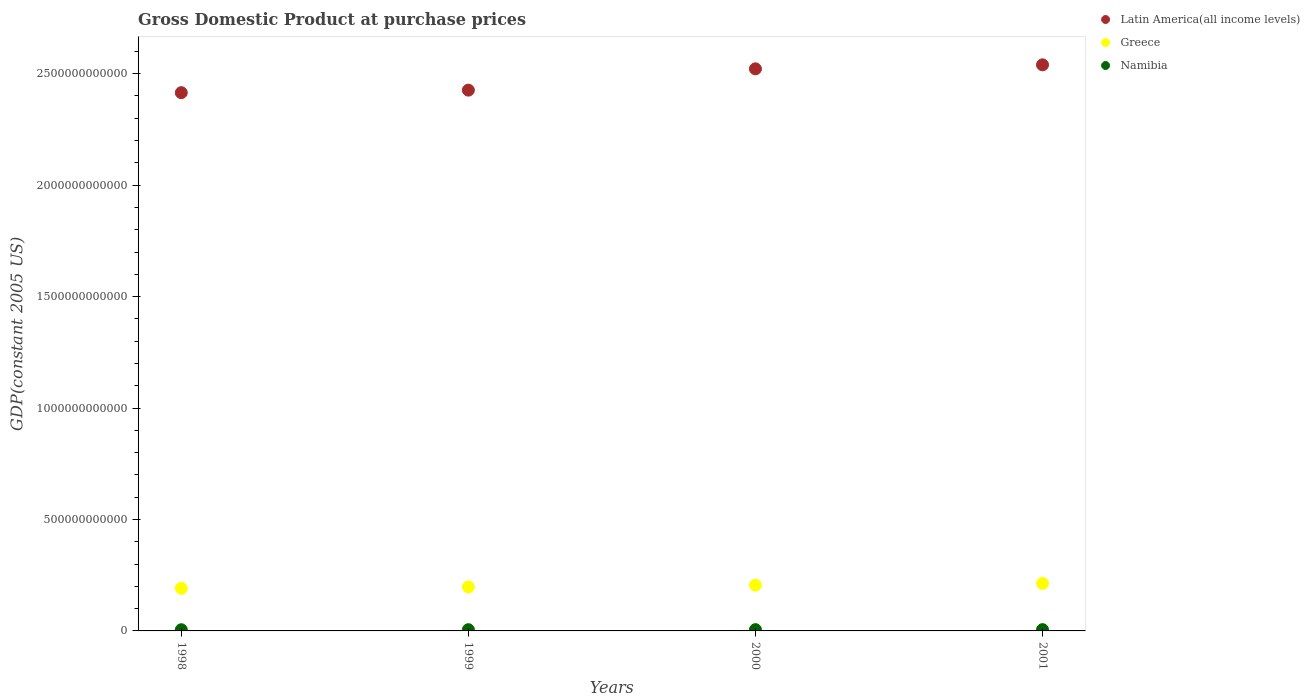How many different coloured dotlines are there?
Make the answer very short. 3. Is the number of dotlines equal to the number of legend labels?
Give a very brief answer. Yes. What is the GDP at purchase prices in Namibia in 2001?
Your answer should be compact. 5.78e+09. Across all years, what is the maximum GDP at purchase prices in Namibia?
Your response must be concise. 5.78e+09. Across all years, what is the minimum GDP at purchase prices in Namibia?
Give a very brief answer. 5.34e+09. In which year was the GDP at purchase prices in Greece maximum?
Provide a short and direct response. 2001. In which year was the GDP at purchase prices in Greece minimum?
Keep it short and to the point. 1998. What is the total GDP at purchase prices in Latin America(all income levels) in the graph?
Offer a terse response. 9.90e+12. What is the difference between the GDP at purchase prices in Greece in 1998 and that in 1999?
Provide a short and direct response. -5.87e+09. What is the difference between the GDP at purchase prices in Namibia in 1999 and the GDP at purchase prices in Latin America(all income levels) in 2000?
Provide a short and direct response. -2.52e+12. What is the average GDP at purchase prices in Latin America(all income levels) per year?
Make the answer very short. 2.48e+12. In the year 2001, what is the difference between the GDP at purchase prices in Namibia and GDP at purchase prices in Greece?
Offer a terse response. -2.07e+11. In how many years, is the GDP at purchase prices in Greece greater than 1100000000000 US$?
Provide a short and direct response. 0. What is the ratio of the GDP at purchase prices in Latin America(all income levels) in 1998 to that in 1999?
Keep it short and to the point. 1. Is the GDP at purchase prices in Latin America(all income levels) in 1999 less than that in 2001?
Provide a succinct answer. Yes. Is the difference between the GDP at purchase prices in Namibia in 1998 and 2001 greater than the difference between the GDP at purchase prices in Greece in 1998 and 2001?
Provide a short and direct response. Yes. What is the difference between the highest and the second highest GDP at purchase prices in Greece?
Ensure brevity in your answer.  7.89e+09. What is the difference between the highest and the lowest GDP at purchase prices in Greece?
Make the answer very short. 2.21e+1. Is the sum of the GDP at purchase prices in Latin America(all income levels) in 1999 and 2001 greater than the maximum GDP at purchase prices in Namibia across all years?
Provide a succinct answer. Yes. Is it the case that in every year, the sum of the GDP at purchase prices in Latin America(all income levels) and GDP at purchase prices in Namibia  is greater than the GDP at purchase prices in Greece?
Offer a very short reply. Yes. Is the GDP at purchase prices in Greece strictly less than the GDP at purchase prices in Namibia over the years?
Your answer should be compact. No. What is the difference between two consecutive major ticks on the Y-axis?
Your answer should be very brief. 5.00e+11. What is the title of the graph?
Your response must be concise. Gross Domestic Product at purchase prices. Does "Spain" appear as one of the legend labels in the graph?
Offer a very short reply. No. What is the label or title of the X-axis?
Provide a short and direct response. Years. What is the label or title of the Y-axis?
Provide a short and direct response. GDP(constant 2005 US). What is the GDP(constant 2005 US) in Latin America(all income levels) in 1998?
Your response must be concise. 2.41e+12. What is the GDP(constant 2005 US) of Greece in 1998?
Give a very brief answer. 1.91e+11. What is the GDP(constant 2005 US) in Namibia in 1998?
Offer a very short reply. 5.34e+09. What is the GDP(constant 2005 US) in Latin America(all income levels) in 1999?
Your answer should be very brief. 2.43e+12. What is the GDP(constant 2005 US) in Greece in 1999?
Offer a terse response. 1.97e+11. What is the GDP(constant 2005 US) of Namibia in 1999?
Offer a terse response. 5.52e+09. What is the GDP(constant 2005 US) of Latin America(all income levels) in 2000?
Keep it short and to the point. 2.52e+12. What is the GDP(constant 2005 US) of Greece in 2000?
Provide a succinct answer. 2.05e+11. What is the GDP(constant 2005 US) of Namibia in 2000?
Make the answer very short. 5.71e+09. What is the GDP(constant 2005 US) of Latin America(all income levels) in 2001?
Make the answer very short. 2.54e+12. What is the GDP(constant 2005 US) in Greece in 2001?
Offer a terse response. 2.13e+11. What is the GDP(constant 2005 US) in Namibia in 2001?
Make the answer very short. 5.78e+09. Across all years, what is the maximum GDP(constant 2005 US) of Latin America(all income levels)?
Offer a terse response. 2.54e+12. Across all years, what is the maximum GDP(constant 2005 US) of Greece?
Keep it short and to the point. 2.13e+11. Across all years, what is the maximum GDP(constant 2005 US) of Namibia?
Offer a very short reply. 5.78e+09. Across all years, what is the minimum GDP(constant 2005 US) of Latin America(all income levels)?
Ensure brevity in your answer.  2.41e+12. Across all years, what is the minimum GDP(constant 2005 US) in Greece?
Ensure brevity in your answer.  1.91e+11. Across all years, what is the minimum GDP(constant 2005 US) of Namibia?
Give a very brief answer. 5.34e+09. What is the total GDP(constant 2005 US) in Latin America(all income levels) in the graph?
Your response must be concise. 9.90e+12. What is the total GDP(constant 2005 US) of Greece in the graph?
Your answer should be very brief. 8.07e+11. What is the total GDP(constant 2005 US) of Namibia in the graph?
Provide a succinct answer. 2.23e+1. What is the difference between the GDP(constant 2005 US) of Latin America(all income levels) in 1998 and that in 1999?
Your answer should be compact. -1.13e+1. What is the difference between the GDP(constant 2005 US) of Greece in 1998 and that in 1999?
Provide a short and direct response. -5.87e+09. What is the difference between the GDP(constant 2005 US) in Namibia in 1998 and that in 1999?
Keep it short and to the point. -1.80e+08. What is the difference between the GDP(constant 2005 US) of Latin America(all income levels) in 1998 and that in 2000?
Give a very brief answer. -1.07e+11. What is the difference between the GDP(constant 2005 US) of Greece in 1998 and that in 2000?
Offer a terse response. -1.42e+1. What is the difference between the GDP(constant 2005 US) of Namibia in 1998 and that in 2000?
Your response must be concise. -3.72e+08. What is the difference between the GDP(constant 2005 US) in Latin America(all income levels) in 1998 and that in 2001?
Make the answer very short. -1.25e+11. What is the difference between the GDP(constant 2005 US) of Greece in 1998 and that in 2001?
Provide a short and direct response. -2.21e+1. What is the difference between the GDP(constant 2005 US) of Namibia in 1998 and that in 2001?
Ensure brevity in your answer.  -4.40e+08. What is the difference between the GDP(constant 2005 US) in Latin America(all income levels) in 1999 and that in 2000?
Offer a very short reply. -9.56e+1. What is the difference between the GDP(constant 2005 US) in Greece in 1999 and that in 2000?
Offer a terse response. -8.29e+09. What is the difference between the GDP(constant 2005 US) in Namibia in 1999 and that in 2000?
Offer a very short reply. -1.93e+08. What is the difference between the GDP(constant 2005 US) in Latin America(all income levels) in 1999 and that in 2001?
Provide a short and direct response. -1.14e+11. What is the difference between the GDP(constant 2005 US) in Greece in 1999 and that in 2001?
Provide a succinct answer. -1.62e+1. What is the difference between the GDP(constant 2005 US) of Namibia in 1999 and that in 2001?
Make the answer very short. -2.60e+08. What is the difference between the GDP(constant 2005 US) of Latin America(all income levels) in 2000 and that in 2001?
Offer a terse response. -1.80e+1. What is the difference between the GDP(constant 2005 US) in Greece in 2000 and that in 2001?
Keep it short and to the point. -7.89e+09. What is the difference between the GDP(constant 2005 US) of Namibia in 2000 and that in 2001?
Offer a terse response. -6.72e+07. What is the difference between the GDP(constant 2005 US) in Latin America(all income levels) in 1998 and the GDP(constant 2005 US) in Greece in 1999?
Provide a short and direct response. 2.22e+12. What is the difference between the GDP(constant 2005 US) of Latin America(all income levels) in 1998 and the GDP(constant 2005 US) of Namibia in 1999?
Give a very brief answer. 2.41e+12. What is the difference between the GDP(constant 2005 US) of Greece in 1998 and the GDP(constant 2005 US) of Namibia in 1999?
Offer a very short reply. 1.86e+11. What is the difference between the GDP(constant 2005 US) of Latin America(all income levels) in 1998 and the GDP(constant 2005 US) of Greece in 2000?
Offer a very short reply. 2.21e+12. What is the difference between the GDP(constant 2005 US) in Latin America(all income levels) in 1998 and the GDP(constant 2005 US) in Namibia in 2000?
Offer a very short reply. 2.41e+12. What is the difference between the GDP(constant 2005 US) of Greece in 1998 and the GDP(constant 2005 US) of Namibia in 2000?
Offer a very short reply. 1.85e+11. What is the difference between the GDP(constant 2005 US) in Latin America(all income levels) in 1998 and the GDP(constant 2005 US) in Greece in 2001?
Provide a short and direct response. 2.20e+12. What is the difference between the GDP(constant 2005 US) in Latin America(all income levels) in 1998 and the GDP(constant 2005 US) in Namibia in 2001?
Offer a terse response. 2.41e+12. What is the difference between the GDP(constant 2005 US) of Greece in 1998 and the GDP(constant 2005 US) of Namibia in 2001?
Provide a short and direct response. 1.85e+11. What is the difference between the GDP(constant 2005 US) in Latin America(all income levels) in 1999 and the GDP(constant 2005 US) in Greece in 2000?
Your response must be concise. 2.22e+12. What is the difference between the GDP(constant 2005 US) of Latin America(all income levels) in 1999 and the GDP(constant 2005 US) of Namibia in 2000?
Make the answer very short. 2.42e+12. What is the difference between the GDP(constant 2005 US) of Greece in 1999 and the GDP(constant 2005 US) of Namibia in 2000?
Make the answer very short. 1.91e+11. What is the difference between the GDP(constant 2005 US) in Latin America(all income levels) in 1999 and the GDP(constant 2005 US) in Greece in 2001?
Your answer should be compact. 2.21e+12. What is the difference between the GDP(constant 2005 US) of Latin America(all income levels) in 1999 and the GDP(constant 2005 US) of Namibia in 2001?
Ensure brevity in your answer.  2.42e+12. What is the difference between the GDP(constant 2005 US) of Greece in 1999 and the GDP(constant 2005 US) of Namibia in 2001?
Your answer should be very brief. 1.91e+11. What is the difference between the GDP(constant 2005 US) in Latin America(all income levels) in 2000 and the GDP(constant 2005 US) in Greece in 2001?
Keep it short and to the point. 2.31e+12. What is the difference between the GDP(constant 2005 US) in Latin America(all income levels) in 2000 and the GDP(constant 2005 US) in Namibia in 2001?
Your response must be concise. 2.52e+12. What is the difference between the GDP(constant 2005 US) in Greece in 2000 and the GDP(constant 2005 US) in Namibia in 2001?
Make the answer very short. 2.00e+11. What is the average GDP(constant 2005 US) in Latin America(all income levels) per year?
Your response must be concise. 2.48e+12. What is the average GDP(constant 2005 US) in Greece per year?
Keep it short and to the point. 2.02e+11. What is the average GDP(constant 2005 US) of Namibia per year?
Your answer should be very brief. 5.58e+09. In the year 1998, what is the difference between the GDP(constant 2005 US) of Latin America(all income levels) and GDP(constant 2005 US) of Greece?
Keep it short and to the point. 2.22e+12. In the year 1998, what is the difference between the GDP(constant 2005 US) in Latin America(all income levels) and GDP(constant 2005 US) in Namibia?
Offer a terse response. 2.41e+12. In the year 1998, what is the difference between the GDP(constant 2005 US) in Greece and GDP(constant 2005 US) in Namibia?
Offer a terse response. 1.86e+11. In the year 1999, what is the difference between the GDP(constant 2005 US) in Latin America(all income levels) and GDP(constant 2005 US) in Greece?
Make the answer very short. 2.23e+12. In the year 1999, what is the difference between the GDP(constant 2005 US) in Latin America(all income levels) and GDP(constant 2005 US) in Namibia?
Make the answer very short. 2.42e+12. In the year 1999, what is the difference between the GDP(constant 2005 US) of Greece and GDP(constant 2005 US) of Namibia?
Make the answer very short. 1.92e+11. In the year 2000, what is the difference between the GDP(constant 2005 US) in Latin America(all income levels) and GDP(constant 2005 US) in Greece?
Offer a very short reply. 2.32e+12. In the year 2000, what is the difference between the GDP(constant 2005 US) in Latin America(all income levels) and GDP(constant 2005 US) in Namibia?
Your answer should be very brief. 2.52e+12. In the year 2000, what is the difference between the GDP(constant 2005 US) in Greece and GDP(constant 2005 US) in Namibia?
Your answer should be compact. 2.00e+11. In the year 2001, what is the difference between the GDP(constant 2005 US) in Latin America(all income levels) and GDP(constant 2005 US) in Greece?
Offer a very short reply. 2.33e+12. In the year 2001, what is the difference between the GDP(constant 2005 US) of Latin America(all income levels) and GDP(constant 2005 US) of Namibia?
Provide a succinct answer. 2.53e+12. In the year 2001, what is the difference between the GDP(constant 2005 US) of Greece and GDP(constant 2005 US) of Namibia?
Provide a succinct answer. 2.07e+11. What is the ratio of the GDP(constant 2005 US) of Latin America(all income levels) in 1998 to that in 1999?
Offer a terse response. 1. What is the ratio of the GDP(constant 2005 US) of Greece in 1998 to that in 1999?
Offer a terse response. 0.97. What is the ratio of the GDP(constant 2005 US) of Namibia in 1998 to that in 1999?
Give a very brief answer. 0.97. What is the ratio of the GDP(constant 2005 US) in Latin America(all income levels) in 1998 to that in 2000?
Offer a terse response. 0.96. What is the ratio of the GDP(constant 2005 US) in Namibia in 1998 to that in 2000?
Your answer should be compact. 0.93. What is the ratio of the GDP(constant 2005 US) in Latin America(all income levels) in 1998 to that in 2001?
Provide a short and direct response. 0.95. What is the ratio of the GDP(constant 2005 US) in Greece in 1998 to that in 2001?
Make the answer very short. 0.9. What is the ratio of the GDP(constant 2005 US) of Namibia in 1998 to that in 2001?
Keep it short and to the point. 0.92. What is the ratio of the GDP(constant 2005 US) in Latin America(all income levels) in 1999 to that in 2000?
Give a very brief answer. 0.96. What is the ratio of the GDP(constant 2005 US) in Greece in 1999 to that in 2000?
Ensure brevity in your answer.  0.96. What is the ratio of the GDP(constant 2005 US) of Namibia in 1999 to that in 2000?
Keep it short and to the point. 0.97. What is the ratio of the GDP(constant 2005 US) of Latin America(all income levels) in 1999 to that in 2001?
Provide a short and direct response. 0.96. What is the ratio of the GDP(constant 2005 US) in Greece in 1999 to that in 2001?
Provide a succinct answer. 0.92. What is the ratio of the GDP(constant 2005 US) of Namibia in 1999 to that in 2001?
Offer a very short reply. 0.95. What is the ratio of the GDP(constant 2005 US) of Namibia in 2000 to that in 2001?
Offer a terse response. 0.99. What is the difference between the highest and the second highest GDP(constant 2005 US) in Latin America(all income levels)?
Your answer should be very brief. 1.80e+1. What is the difference between the highest and the second highest GDP(constant 2005 US) of Greece?
Your answer should be compact. 7.89e+09. What is the difference between the highest and the second highest GDP(constant 2005 US) of Namibia?
Make the answer very short. 6.72e+07. What is the difference between the highest and the lowest GDP(constant 2005 US) of Latin America(all income levels)?
Ensure brevity in your answer.  1.25e+11. What is the difference between the highest and the lowest GDP(constant 2005 US) in Greece?
Make the answer very short. 2.21e+1. What is the difference between the highest and the lowest GDP(constant 2005 US) of Namibia?
Ensure brevity in your answer.  4.40e+08. 